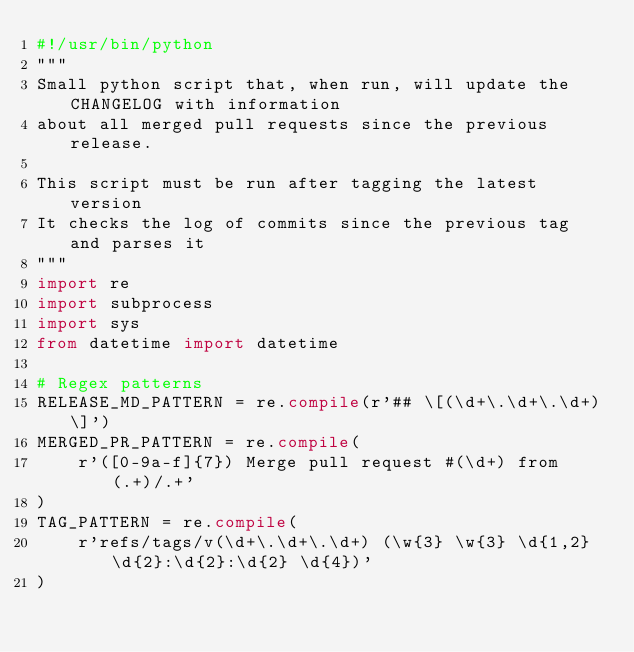Convert code to text. <code><loc_0><loc_0><loc_500><loc_500><_Python_>#!/usr/bin/python
"""
Small python script that, when run, will update the CHANGELOG with information
about all merged pull requests since the previous release.

This script must be run after tagging the latest version
It checks the log of commits since the previous tag and parses it
"""
import re
import subprocess
import sys
from datetime import datetime

# Regex patterns
RELEASE_MD_PATTERN = re.compile(r'## \[(\d+\.\d+\.\d+)\]')
MERGED_PR_PATTERN = re.compile(
    r'([0-9a-f]{7}) Merge pull request #(\d+) from (.+)/.+'
)
TAG_PATTERN = re.compile(
    r'refs/tags/v(\d+\.\d+\.\d+) (\w{3} \w{3} \d{1,2} \d{2}:\d{2}:\d{2} \d{4})'
)
</code> 